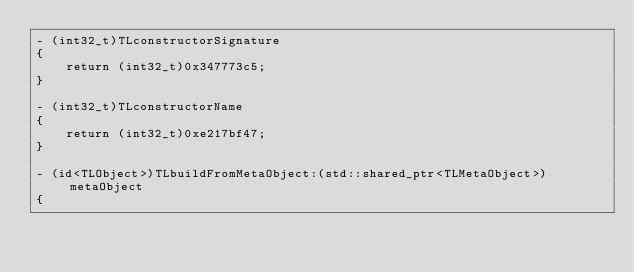<code> <loc_0><loc_0><loc_500><loc_500><_ObjectiveC_>- (int32_t)TLconstructorSignature
{
    return (int32_t)0x347773c5;
}

- (int32_t)TLconstructorName
{
    return (int32_t)0xe217bf47;
}

- (id<TLObject>)TLbuildFromMetaObject:(std::shared_ptr<TLMetaObject>)metaObject
{</code> 